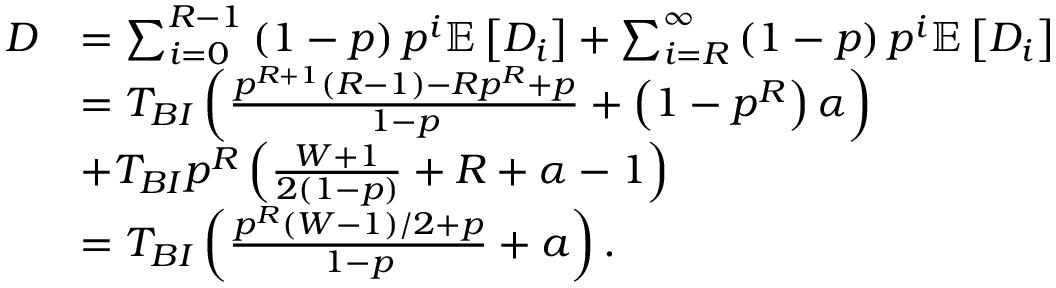Convert formula to latex. <formula><loc_0><loc_0><loc_500><loc_500>\begin{array} { r l } { D } & { = \sum _ { i = 0 } ^ { R - 1 } \left ( 1 - p \right ) p ^ { i } \mathbb { E } \left [ { D } _ { i } \right ] + \sum _ { i = R } ^ { \infty } \left ( 1 - p \right ) p ^ { i } \mathbb { E } \left [ { D } _ { i } \right ] } \\ & { = T _ { B I } \left ( \frac { p ^ { R + 1 } \left ( R - 1 \right ) - R p ^ { R } + p } { 1 - p } + \left ( 1 - p ^ { R } \right ) \alpha \right ) } \\ & { + T _ { B I } p ^ { R } \left ( \frac { W + 1 } { 2 ( 1 - p ) } + R + \alpha - 1 \right ) } \\ & { = T _ { B I } \left ( \frac { p ^ { R } ( { W - 1 } ) / { 2 } + p } { 1 - p } + a \right ) . } \end{array}</formula> 